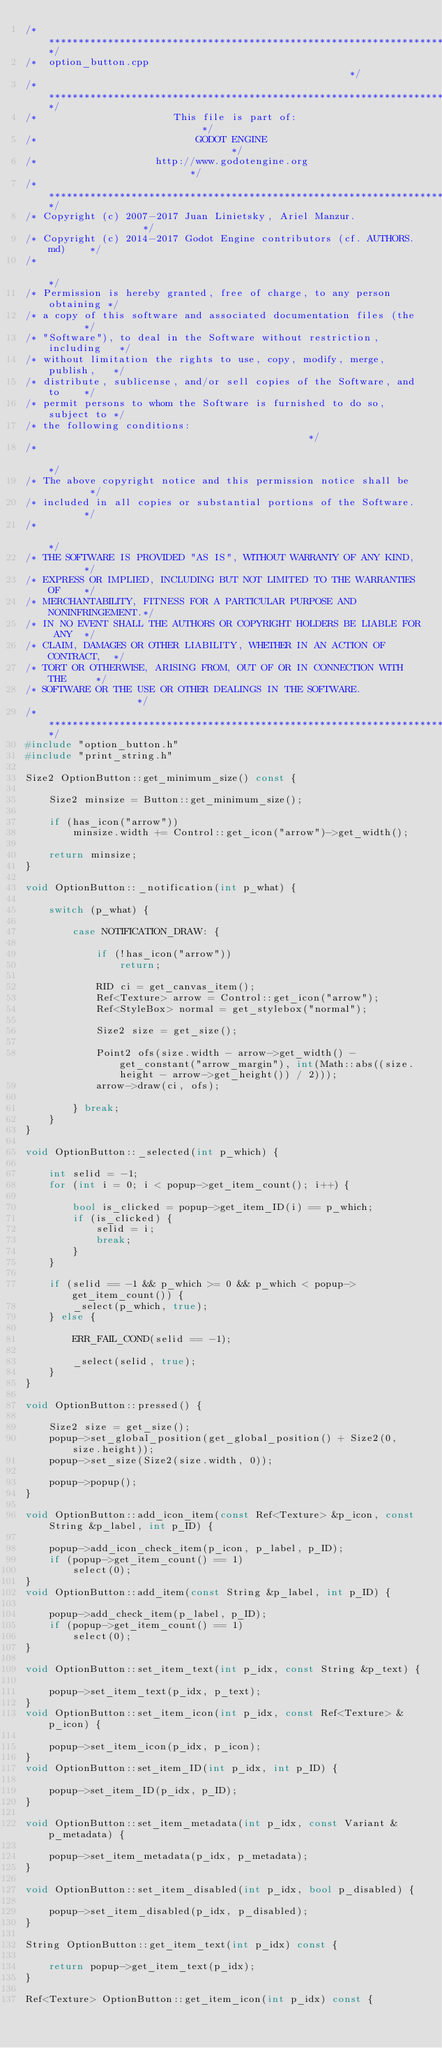Convert code to text. <code><loc_0><loc_0><loc_500><loc_500><_C++_>/*************************************************************************/
/*  option_button.cpp                                                    */
/*************************************************************************/
/*                       This file is part of:                           */
/*                           GODOT ENGINE                                */
/*                    http://www.godotengine.org                         */
/*************************************************************************/
/* Copyright (c) 2007-2017 Juan Linietsky, Ariel Manzur.                 */
/* Copyright (c) 2014-2017 Godot Engine contributors (cf. AUTHORS.md)    */
/*                                                                       */
/* Permission is hereby granted, free of charge, to any person obtaining */
/* a copy of this software and associated documentation files (the       */
/* "Software"), to deal in the Software without restriction, including   */
/* without limitation the rights to use, copy, modify, merge, publish,   */
/* distribute, sublicense, and/or sell copies of the Software, and to    */
/* permit persons to whom the Software is furnished to do so, subject to */
/* the following conditions:                                             */
/*                                                                       */
/* The above copyright notice and this permission notice shall be        */
/* included in all copies or substantial portions of the Software.       */
/*                                                                       */
/* THE SOFTWARE IS PROVIDED "AS IS", WITHOUT WARRANTY OF ANY KIND,       */
/* EXPRESS OR IMPLIED, INCLUDING BUT NOT LIMITED TO THE WARRANTIES OF    */
/* MERCHANTABILITY, FITNESS FOR A PARTICULAR PURPOSE AND NONINFRINGEMENT.*/
/* IN NO EVENT SHALL THE AUTHORS OR COPYRIGHT HOLDERS BE LIABLE FOR ANY  */
/* CLAIM, DAMAGES OR OTHER LIABILITY, WHETHER IN AN ACTION OF CONTRACT,  */
/* TORT OR OTHERWISE, ARISING FROM, OUT OF OR IN CONNECTION WITH THE     */
/* SOFTWARE OR THE USE OR OTHER DEALINGS IN THE SOFTWARE.                */
/*************************************************************************/
#include "option_button.h"
#include "print_string.h"

Size2 OptionButton::get_minimum_size() const {

	Size2 minsize = Button::get_minimum_size();

	if (has_icon("arrow"))
		minsize.width += Control::get_icon("arrow")->get_width();

	return minsize;
}

void OptionButton::_notification(int p_what) {

	switch (p_what) {

		case NOTIFICATION_DRAW: {

			if (!has_icon("arrow"))
				return;

			RID ci = get_canvas_item();
			Ref<Texture> arrow = Control::get_icon("arrow");
			Ref<StyleBox> normal = get_stylebox("normal");

			Size2 size = get_size();

			Point2 ofs(size.width - arrow->get_width() - get_constant("arrow_margin"), int(Math::abs((size.height - arrow->get_height()) / 2)));
			arrow->draw(ci, ofs);

		} break;
	}
}

void OptionButton::_selected(int p_which) {

	int selid = -1;
	for (int i = 0; i < popup->get_item_count(); i++) {

		bool is_clicked = popup->get_item_ID(i) == p_which;
		if (is_clicked) {
			selid = i;
			break;
		}
	}

	if (selid == -1 && p_which >= 0 && p_which < popup->get_item_count()) {
		_select(p_which, true);
	} else {

		ERR_FAIL_COND(selid == -1);

		_select(selid, true);
	}
}

void OptionButton::pressed() {

	Size2 size = get_size();
	popup->set_global_position(get_global_position() + Size2(0, size.height));
	popup->set_size(Size2(size.width, 0));

	popup->popup();
}

void OptionButton::add_icon_item(const Ref<Texture> &p_icon, const String &p_label, int p_ID) {

	popup->add_icon_check_item(p_icon, p_label, p_ID);
	if (popup->get_item_count() == 1)
		select(0);
}
void OptionButton::add_item(const String &p_label, int p_ID) {

	popup->add_check_item(p_label, p_ID);
	if (popup->get_item_count() == 1)
		select(0);
}

void OptionButton::set_item_text(int p_idx, const String &p_text) {

	popup->set_item_text(p_idx, p_text);
}
void OptionButton::set_item_icon(int p_idx, const Ref<Texture> &p_icon) {

	popup->set_item_icon(p_idx, p_icon);
}
void OptionButton::set_item_ID(int p_idx, int p_ID) {

	popup->set_item_ID(p_idx, p_ID);
}

void OptionButton::set_item_metadata(int p_idx, const Variant &p_metadata) {

	popup->set_item_metadata(p_idx, p_metadata);
}

void OptionButton::set_item_disabled(int p_idx, bool p_disabled) {

	popup->set_item_disabled(p_idx, p_disabled);
}

String OptionButton::get_item_text(int p_idx) const {

	return popup->get_item_text(p_idx);
}

Ref<Texture> OptionButton::get_item_icon(int p_idx) const {
</code> 